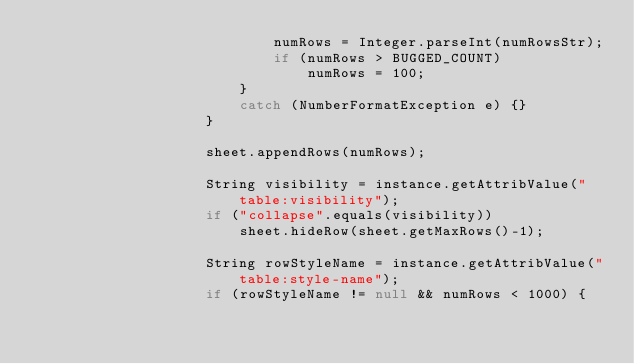<code> <loc_0><loc_0><loc_500><loc_500><_Java_>                            numRows = Integer.parseInt(numRowsStr);
                            if (numRows > BUGGED_COUNT)
                                numRows = 100;
                        }
                        catch (NumberFormatException e) {}
                    }

                    sheet.appendRows(numRows);

                    String visibility = instance.getAttribValue("table:visibility");
                    if ("collapse".equals(visibility))
                        sheet.hideRow(sheet.getMaxRows()-1);

                    String rowStyleName = instance.getAttribValue("table:style-name");
                    if (rowStyleName != null && numRows < 1000) {</code> 